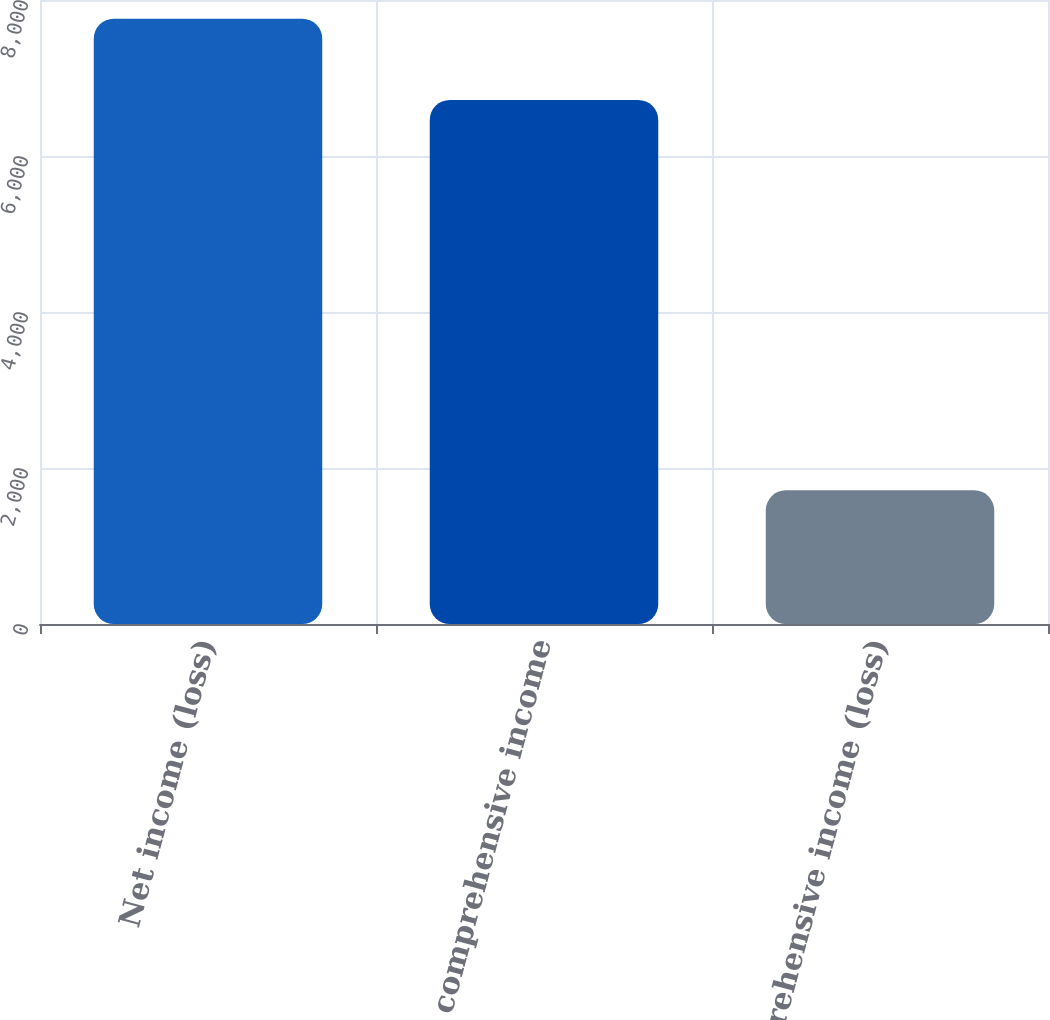Convert chart. <chart><loc_0><loc_0><loc_500><loc_500><bar_chart><fcel>Net income (loss)<fcel>Other comprehensive income<fcel>Comprehensive income (loss)<nl><fcel>7761<fcel>6719<fcel>1713.9<nl></chart> 